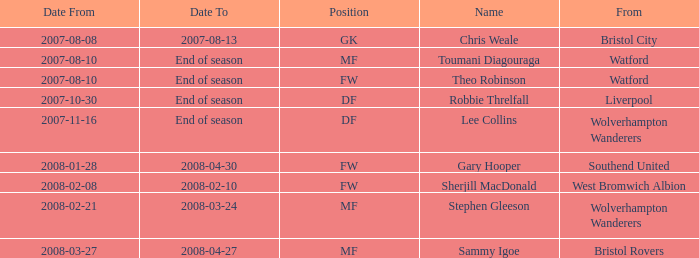What date did Toumani Diagouraga, who played position MF, start? 2007-08-10. 